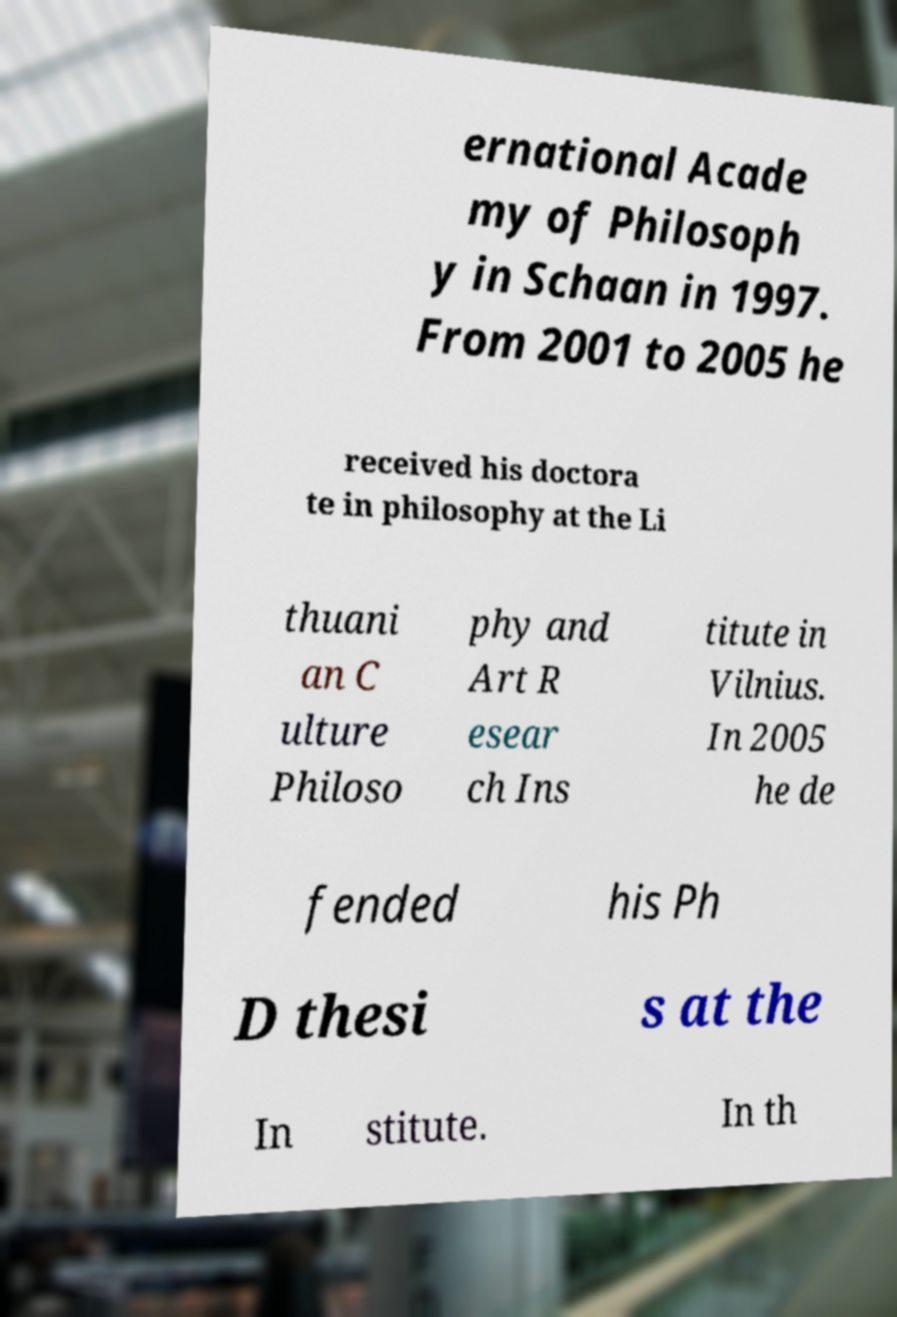Please identify and transcribe the text found in this image. ernational Acade my of Philosoph y in Schaan in 1997. From 2001 to 2005 he received his doctora te in philosophy at the Li thuani an C ulture Philoso phy and Art R esear ch Ins titute in Vilnius. In 2005 he de fended his Ph D thesi s at the In stitute. In th 